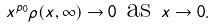<formula> <loc_0><loc_0><loc_500><loc_500>x ^ { p _ { 0 } } \rho ( x , \infty ) \to 0 \text { as } x \to 0 .</formula> 